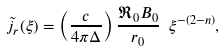Convert formula to latex. <formula><loc_0><loc_0><loc_500><loc_500>\tilde { j } _ { r } ( \xi ) = \left ( \frac { c } { 4 \pi \Delta } \right ) \frac { \Re _ { 0 } B _ { 0 } } { r _ { 0 } } \ \xi ^ { - ( 2 - n ) } ,</formula> 